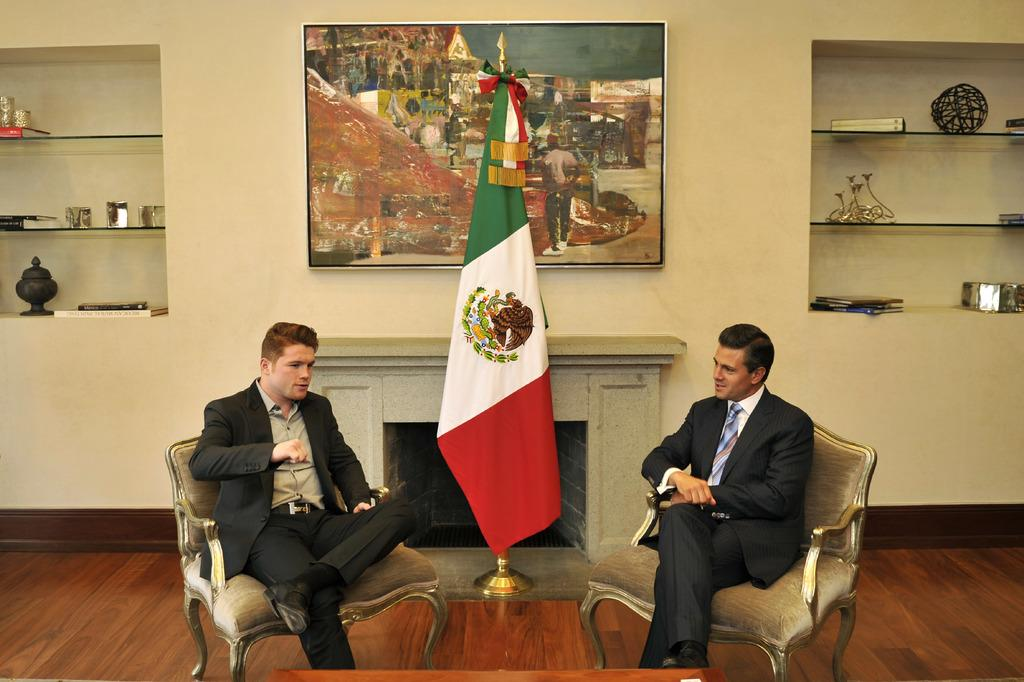What are the persons in the image wearing? The persons in the image are wearing black suits. What are the persons doing while wearing the suits? The persons are sitting in chairs and speaking to each other. What is present between the persons? There is a table in front of the persons. What can be seen in the image besides the persons and the table? There is a flag and a scenery in the background of the image. What type of clam is visible on the table in the image? There is no clam present on the table in the image. How many eyes can be seen on the persons in the image? The persons in the image do not have visible eyes, as their faces are not shown. 